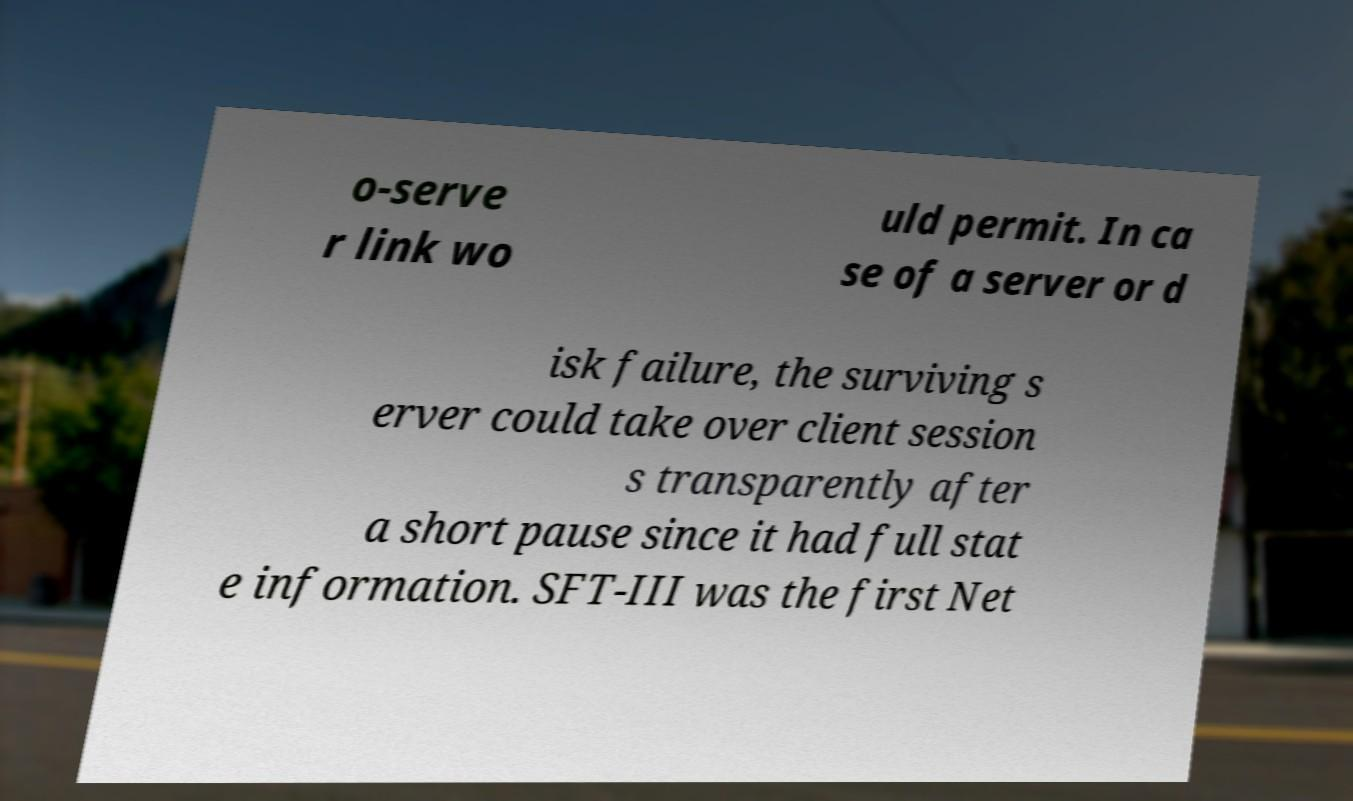I need the written content from this picture converted into text. Can you do that? o-serve r link wo uld permit. In ca se of a server or d isk failure, the surviving s erver could take over client session s transparently after a short pause since it had full stat e information. SFT-III was the first Net 